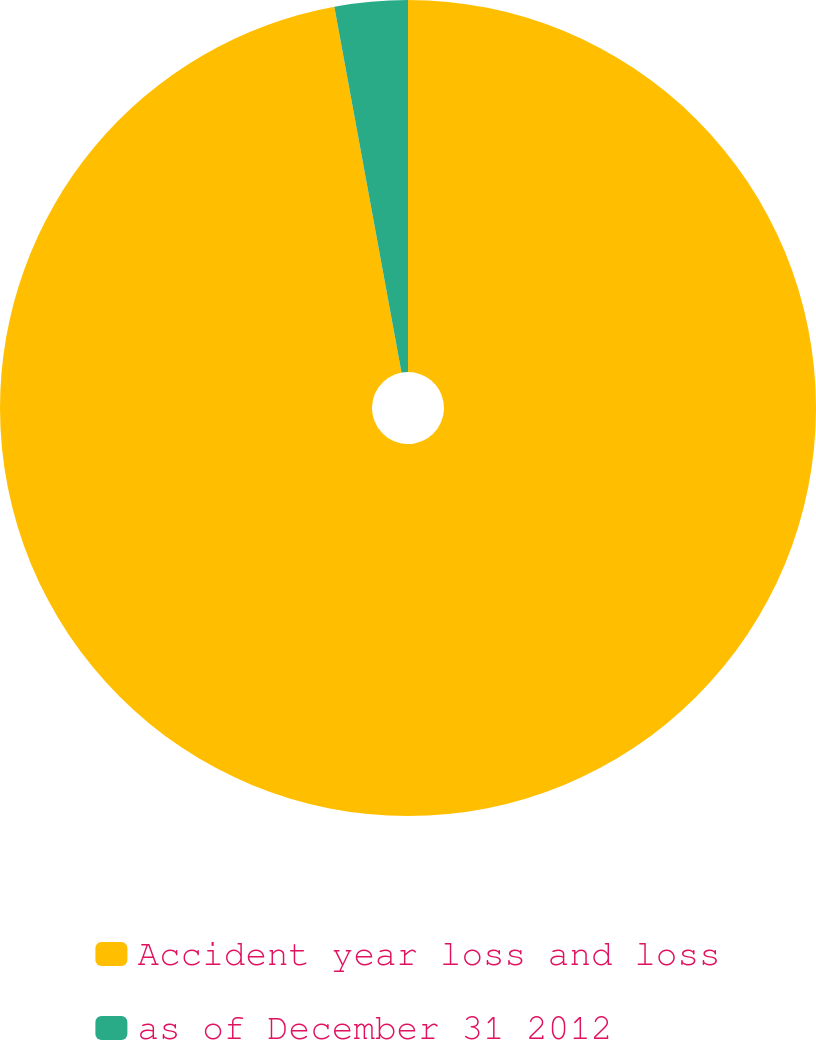Convert chart. <chart><loc_0><loc_0><loc_500><loc_500><pie_chart><fcel>Accident year loss and loss<fcel>as of December 31 2012<nl><fcel>97.11%<fcel>2.89%<nl></chart> 